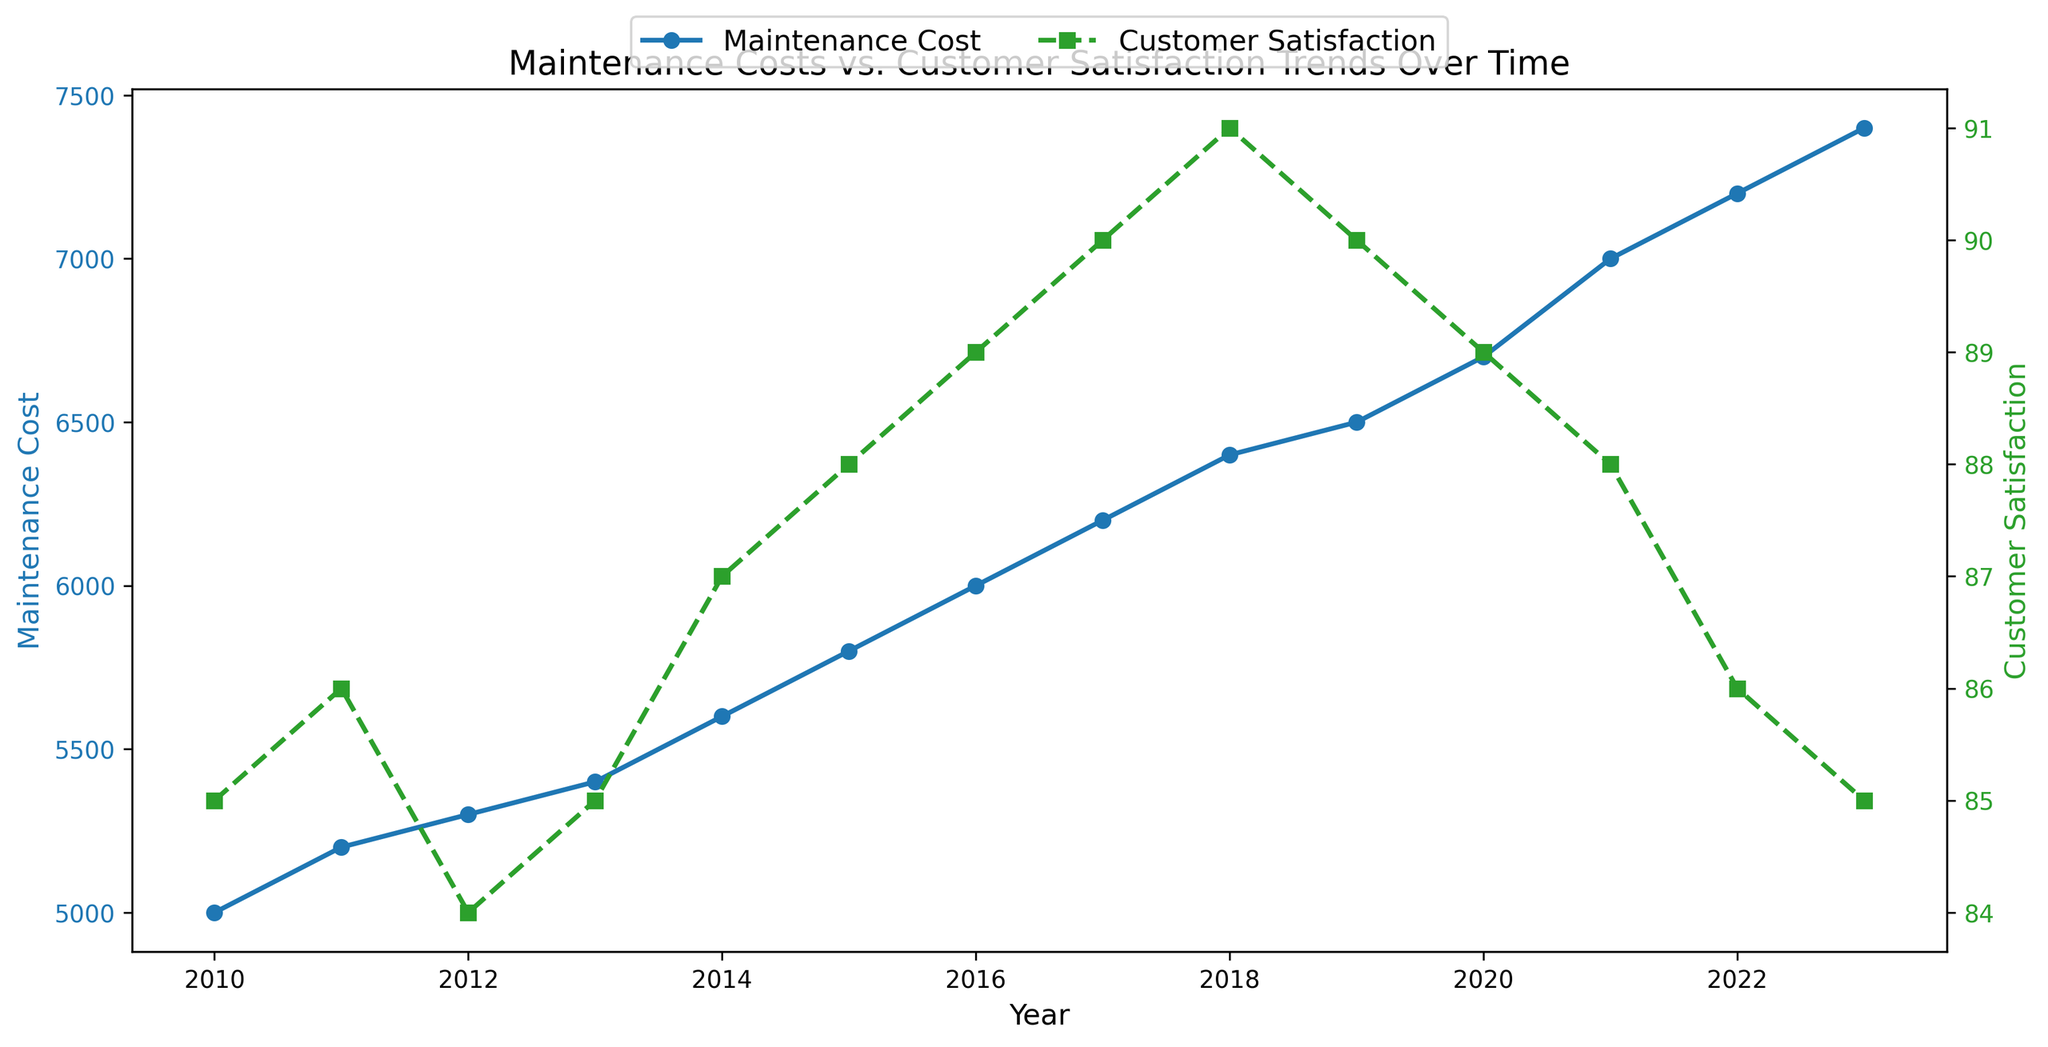What's the general trend of maintenance costs over the years? By looking at the line for maintenance costs (blue line with circle markers), we see that the costs generally increase from 2010 to 2023.
Answer: Increasing Comparing 2011 and 2012, which year had a higher customer satisfaction rating? The green line with square markers shows the customer satisfaction ratings. In 2011 it's at 86, and in 2012 it's at 84.
Answer: 2011 In which year did the customer satisfaction rating peak? The green line with square markers shows the customer satisfaction ratings. The highest point is 91 in 2018.
Answer: 2018 What's the difference in maintenance costs between 2010 and 2023? Maintenance costs in 2010 are 5000 and in 2023 they are 7400. The difference is 7400 - 5000.
Answer: 2400 During which year(s) did maintenance costs equal 6500? The blue line with circle markers shows the maintenance costs. 6500 is the value for the year 2019.
Answer: 2019 How does the customer satisfaction trend behave from 2017 to 2021? From the green line with square markers, customer satisfaction increases from 2017 to 2018 (90 to 91), then subsequently decreases from 2018 to 2021 (91 to 88).
Answer: Increases then decreases Is there any correlation between maintenance cost and customer satisfaction? Visually inspecting the lines, as maintenance costs rise steadily, customer satisfaction does not follow the same steady trend. Some years show correlation but others do not, indicating no clear correlation.
Answer: No clear correlation In how many years is customer satisfaction rated above 88? Customer satisfaction ratings above 88 are in the years 2016, 2017, and 2018. There are 3 such years.
Answer: 3 From the visual trends, which value increased more drastically, maintenance cost or customer satisfaction? Maintenance costs (blue line) show a steady and significant increase from 5000 to 7400. Customer satisfaction (green line) shows more fluctuations and less drastic changes.
Answer: Maintenance cost 